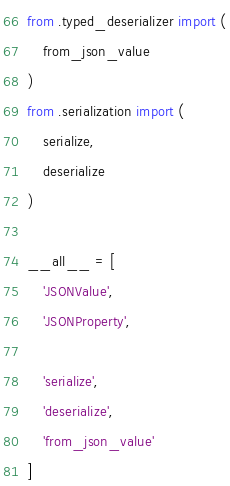<code> <loc_0><loc_0><loc_500><loc_500><_Python_>from .typed_deserializer import (
    from_json_value
)
from .serialization import (
    serialize,
    deserialize
)

__all__ = [
    'JSONValue',
    'JSONProperty',

    'serialize',
    'deserialize',
    'from_json_value'
]
</code> 